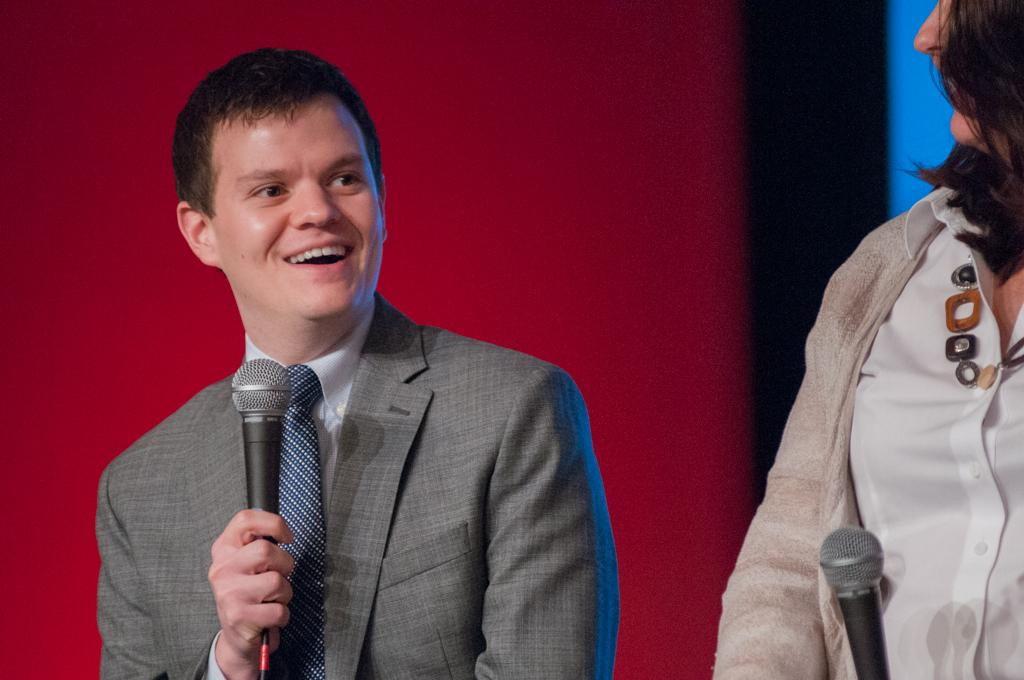What is the man in the image holding? The man is holding a microphone in his hand. What is the man's facial expression in the image? The man has a smile on his face. Who else is present in the image? There is a woman in the image. What is the woman holding in the image? The woman is holding a microphone. What type of flag can be seen waving in the background of the image? There is no flag present in the image. What kind of brush is the woman using to paint in the image? There is no brush or painting activity depicted in the image. 